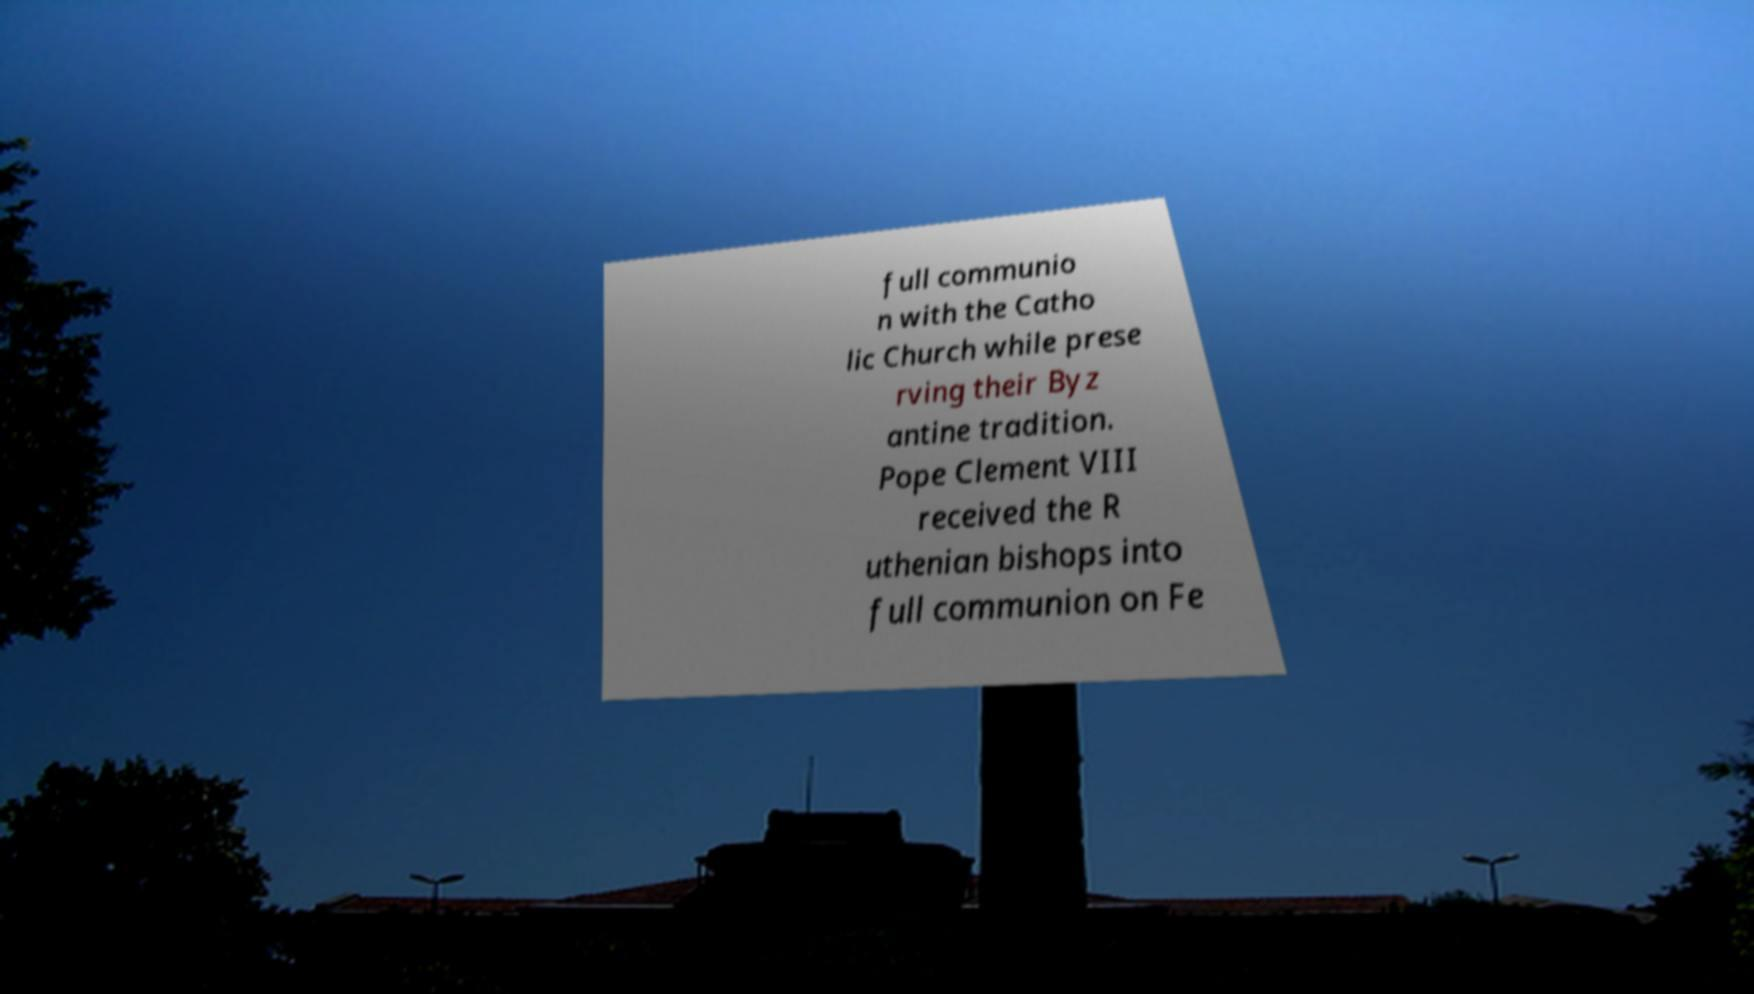Could you extract and type out the text from this image? full communio n with the Catho lic Church while prese rving their Byz antine tradition. Pope Clement VIII received the R uthenian bishops into full communion on Fe 